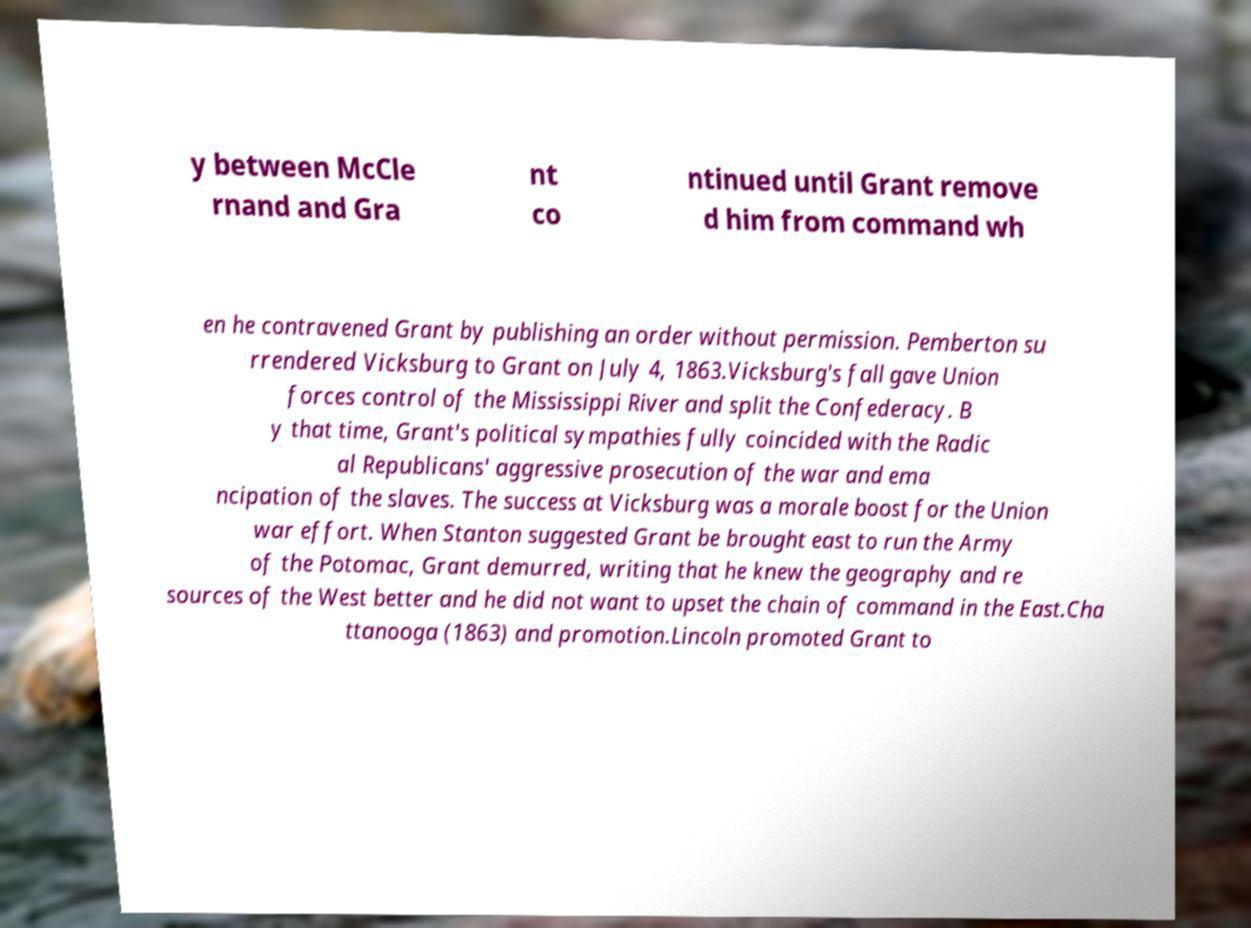I need the written content from this picture converted into text. Can you do that? y between McCle rnand and Gra nt co ntinued until Grant remove d him from command wh en he contravened Grant by publishing an order without permission. Pemberton su rrendered Vicksburg to Grant on July 4, 1863.Vicksburg's fall gave Union forces control of the Mississippi River and split the Confederacy. B y that time, Grant's political sympathies fully coincided with the Radic al Republicans' aggressive prosecution of the war and ema ncipation of the slaves. The success at Vicksburg was a morale boost for the Union war effort. When Stanton suggested Grant be brought east to run the Army of the Potomac, Grant demurred, writing that he knew the geography and re sources of the West better and he did not want to upset the chain of command in the East.Cha ttanooga (1863) and promotion.Lincoln promoted Grant to 